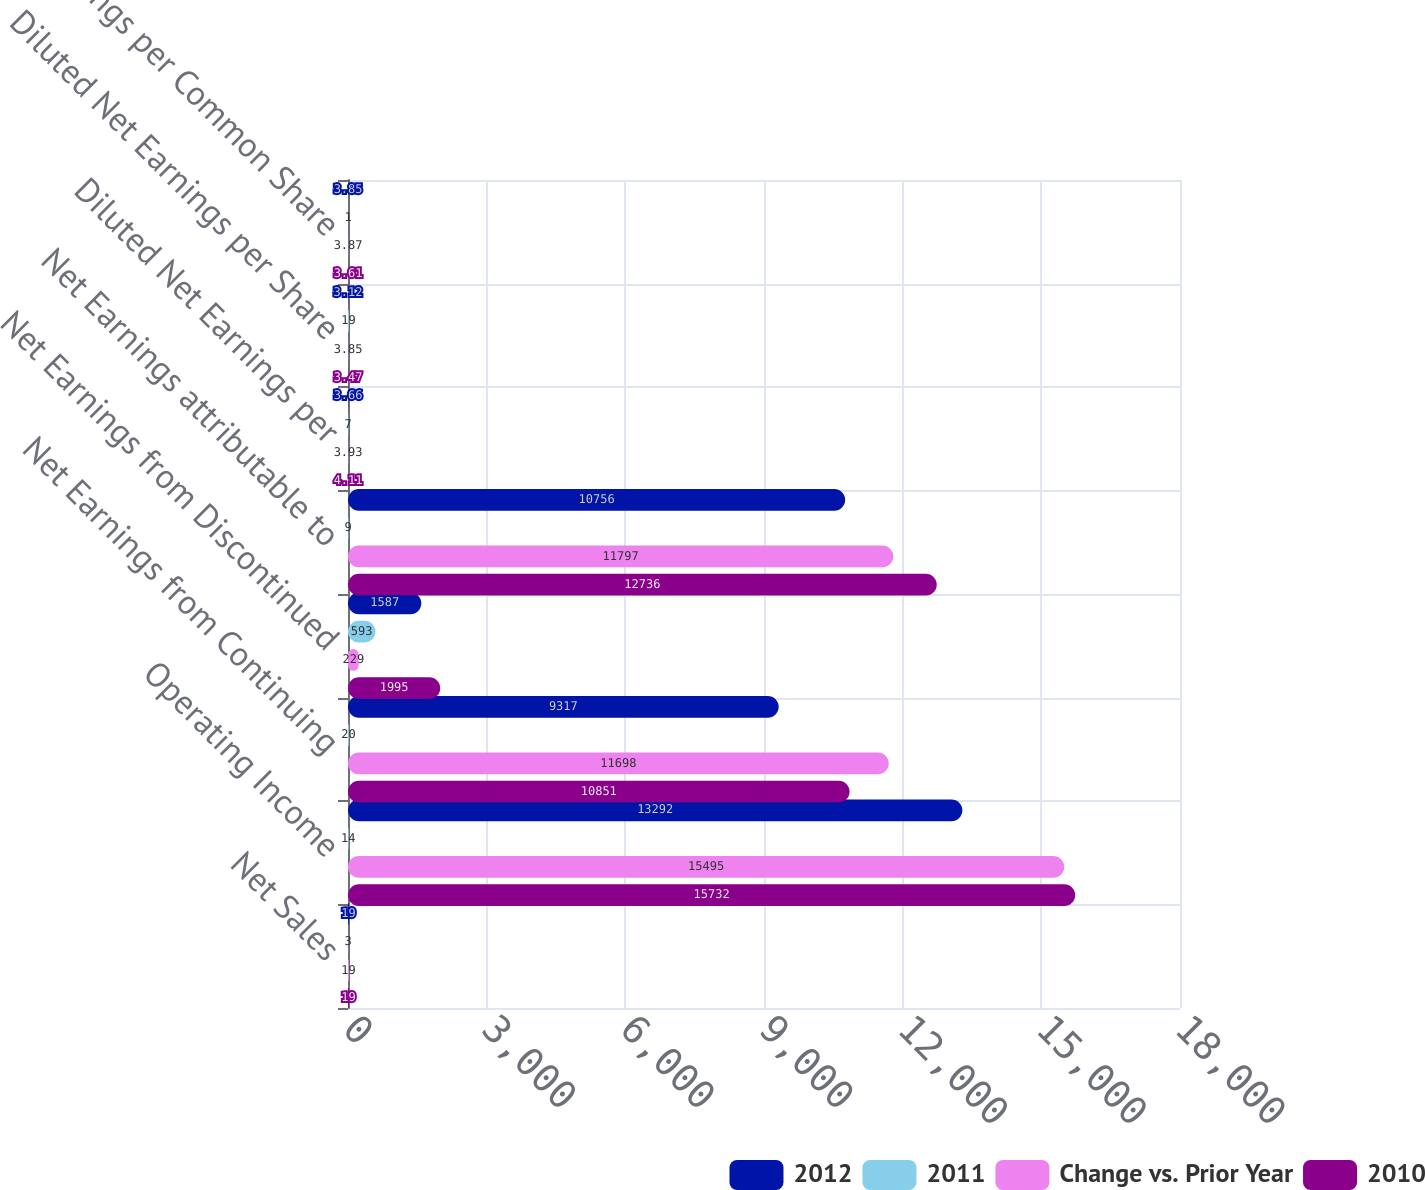Convert chart to OTSL. <chart><loc_0><loc_0><loc_500><loc_500><stacked_bar_chart><ecel><fcel>Net Sales<fcel>Operating Income<fcel>Net Earnings from Continuing<fcel>Net Earnings from Discontinued<fcel>Net Earnings attributable to<fcel>Diluted Net Earnings per<fcel>Diluted Net Earnings per Share<fcel>Core Earnings per Common Share<nl><fcel>2012<fcel>19<fcel>13292<fcel>9317<fcel>1587<fcel>10756<fcel>3.66<fcel>3.12<fcel>3.85<nl><fcel>2011<fcel>3<fcel>14<fcel>20<fcel>593<fcel>9<fcel>7<fcel>19<fcel>1<nl><fcel>Change vs. Prior Year<fcel>19<fcel>15495<fcel>11698<fcel>229<fcel>11797<fcel>3.93<fcel>3.85<fcel>3.87<nl><fcel>2010<fcel>19<fcel>15732<fcel>10851<fcel>1995<fcel>12736<fcel>4.11<fcel>3.47<fcel>3.61<nl></chart> 